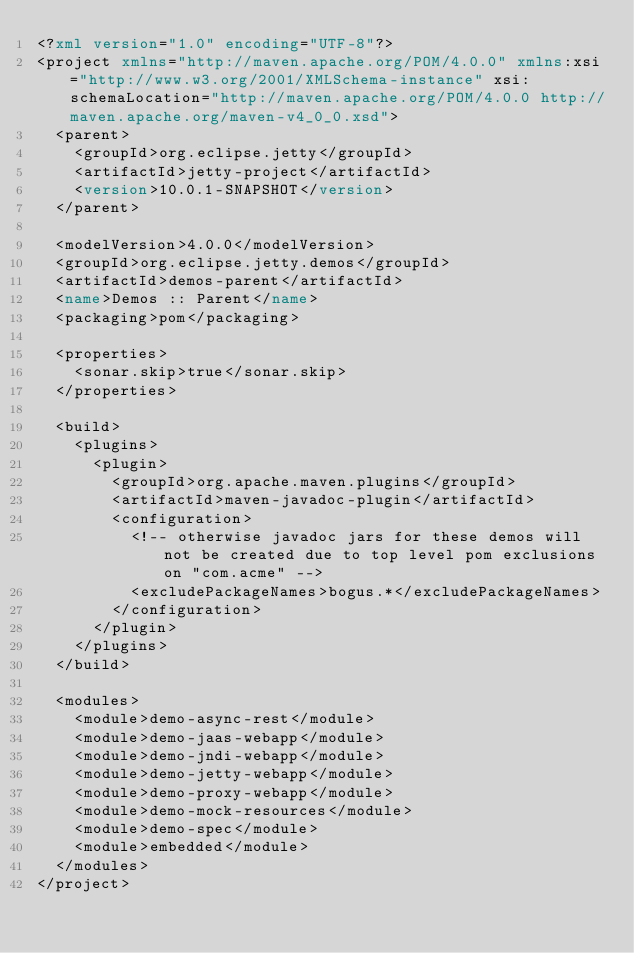<code> <loc_0><loc_0><loc_500><loc_500><_XML_><?xml version="1.0" encoding="UTF-8"?>
<project xmlns="http://maven.apache.org/POM/4.0.0" xmlns:xsi="http://www.w3.org/2001/XMLSchema-instance" xsi:schemaLocation="http://maven.apache.org/POM/4.0.0 http://maven.apache.org/maven-v4_0_0.xsd">
  <parent>
    <groupId>org.eclipse.jetty</groupId>
    <artifactId>jetty-project</artifactId>
    <version>10.0.1-SNAPSHOT</version>
  </parent>

  <modelVersion>4.0.0</modelVersion>
  <groupId>org.eclipse.jetty.demos</groupId>
  <artifactId>demos-parent</artifactId>
  <name>Demos :: Parent</name>
  <packaging>pom</packaging>

  <properties>
    <sonar.skip>true</sonar.skip>
  </properties>

  <build>
    <plugins>
      <plugin>
        <groupId>org.apache.maven.plugins</groupId>
        <artifactId>maven-javadoc-plugin</artifactId>
        <configuration>
          <!-- otherwise javadoc jars for these demos will not be created due to top level pom exclusions on "com.acme" -->
          <excludePackageNames>bogus.*</excludePackageNames>
        </configuration>
      </plugin>
    </plugins>
  </build>

  <modules>
    <module>demo-async-rest</module>
    <module>demo-jaas-webapp</module>
    <module>demo-jndi-webapp</module>
    <module>demo-jetty-webapp</module>
    <module>demo-proxy-webapp</module>
    <module>demo-mock-resources</module>
    <module>demo-spec</module>
    <module>embedded</module>
  </modules>
</project>
</code> 